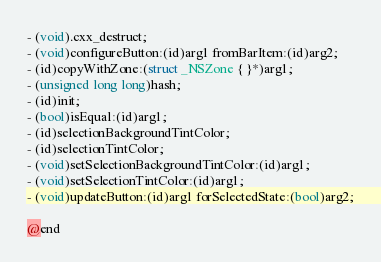<code> <loc_0><loc_0><loc_500><loc_500><_C_>
- (void).cxx_destruct;
- (void)configureButton:(id)arg1 fromBarItem:(id)arg2;
- (id)copyWithZone:(struct _NSZone { }*)arg1;
- (unsigned long long)hash;
- (id)init;
- (bool)isEqual:(id)arg1;
- (id)selectionBackgroundTintColor;
- (id)selectionTintColor;
- (void)setSelectionBackgroundTintColor:(id)arg1;
- (void)setSelectionTintColor:(id)arg1;
- (void)updateButton:(id)arg1 forSelectedState:(bool)arg2;

@end
</code> 